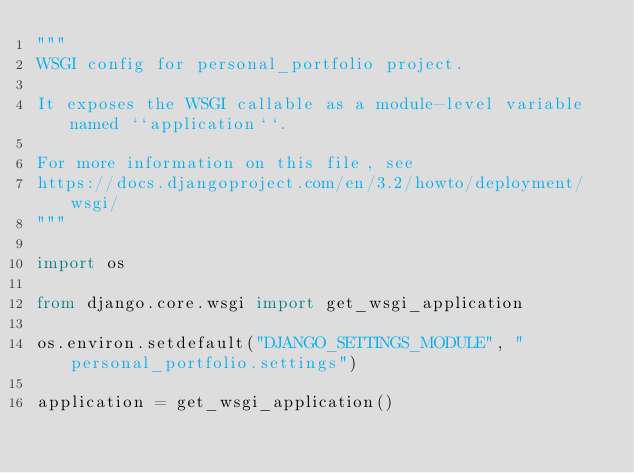<code> <loc_0><loc_0><loc_500><loc_500><_Python_>"""
WSGI config for personal_portfolio project.

It exposes the WSGI callable as a module-level variable named ``application``.

For more information on this file, see
https://docs.djangoproject.com/en/3.2/howto/deployment/wsgi/
"""

import os

from django.core.wsgi import get_wsgi_application

os.environ.setdefault("DJANGO_SETTINGS_MODULE", "personal_portfolio.settings")

application = get_wsgi_application()
</code> 